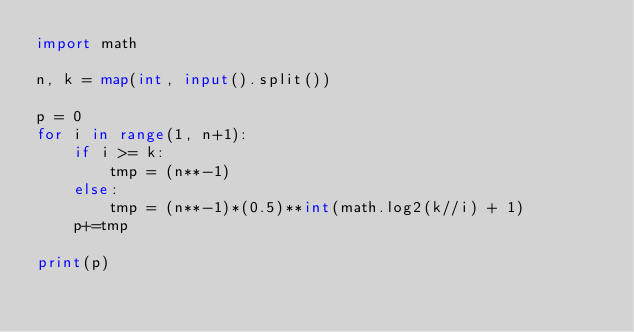<code> <loc_0><loc_0><loc_500><loc_500><_Python_>import math

n, k = map(int, input().split())

p = 0
for i in range(1, n+1):
    if i >= k:
        tmp = (n**-1)
    else:
        tmp = (n**-1)*(0.5)**int(math.log2(k//i) + 1)
    p+=tmp

print(p)</code> 